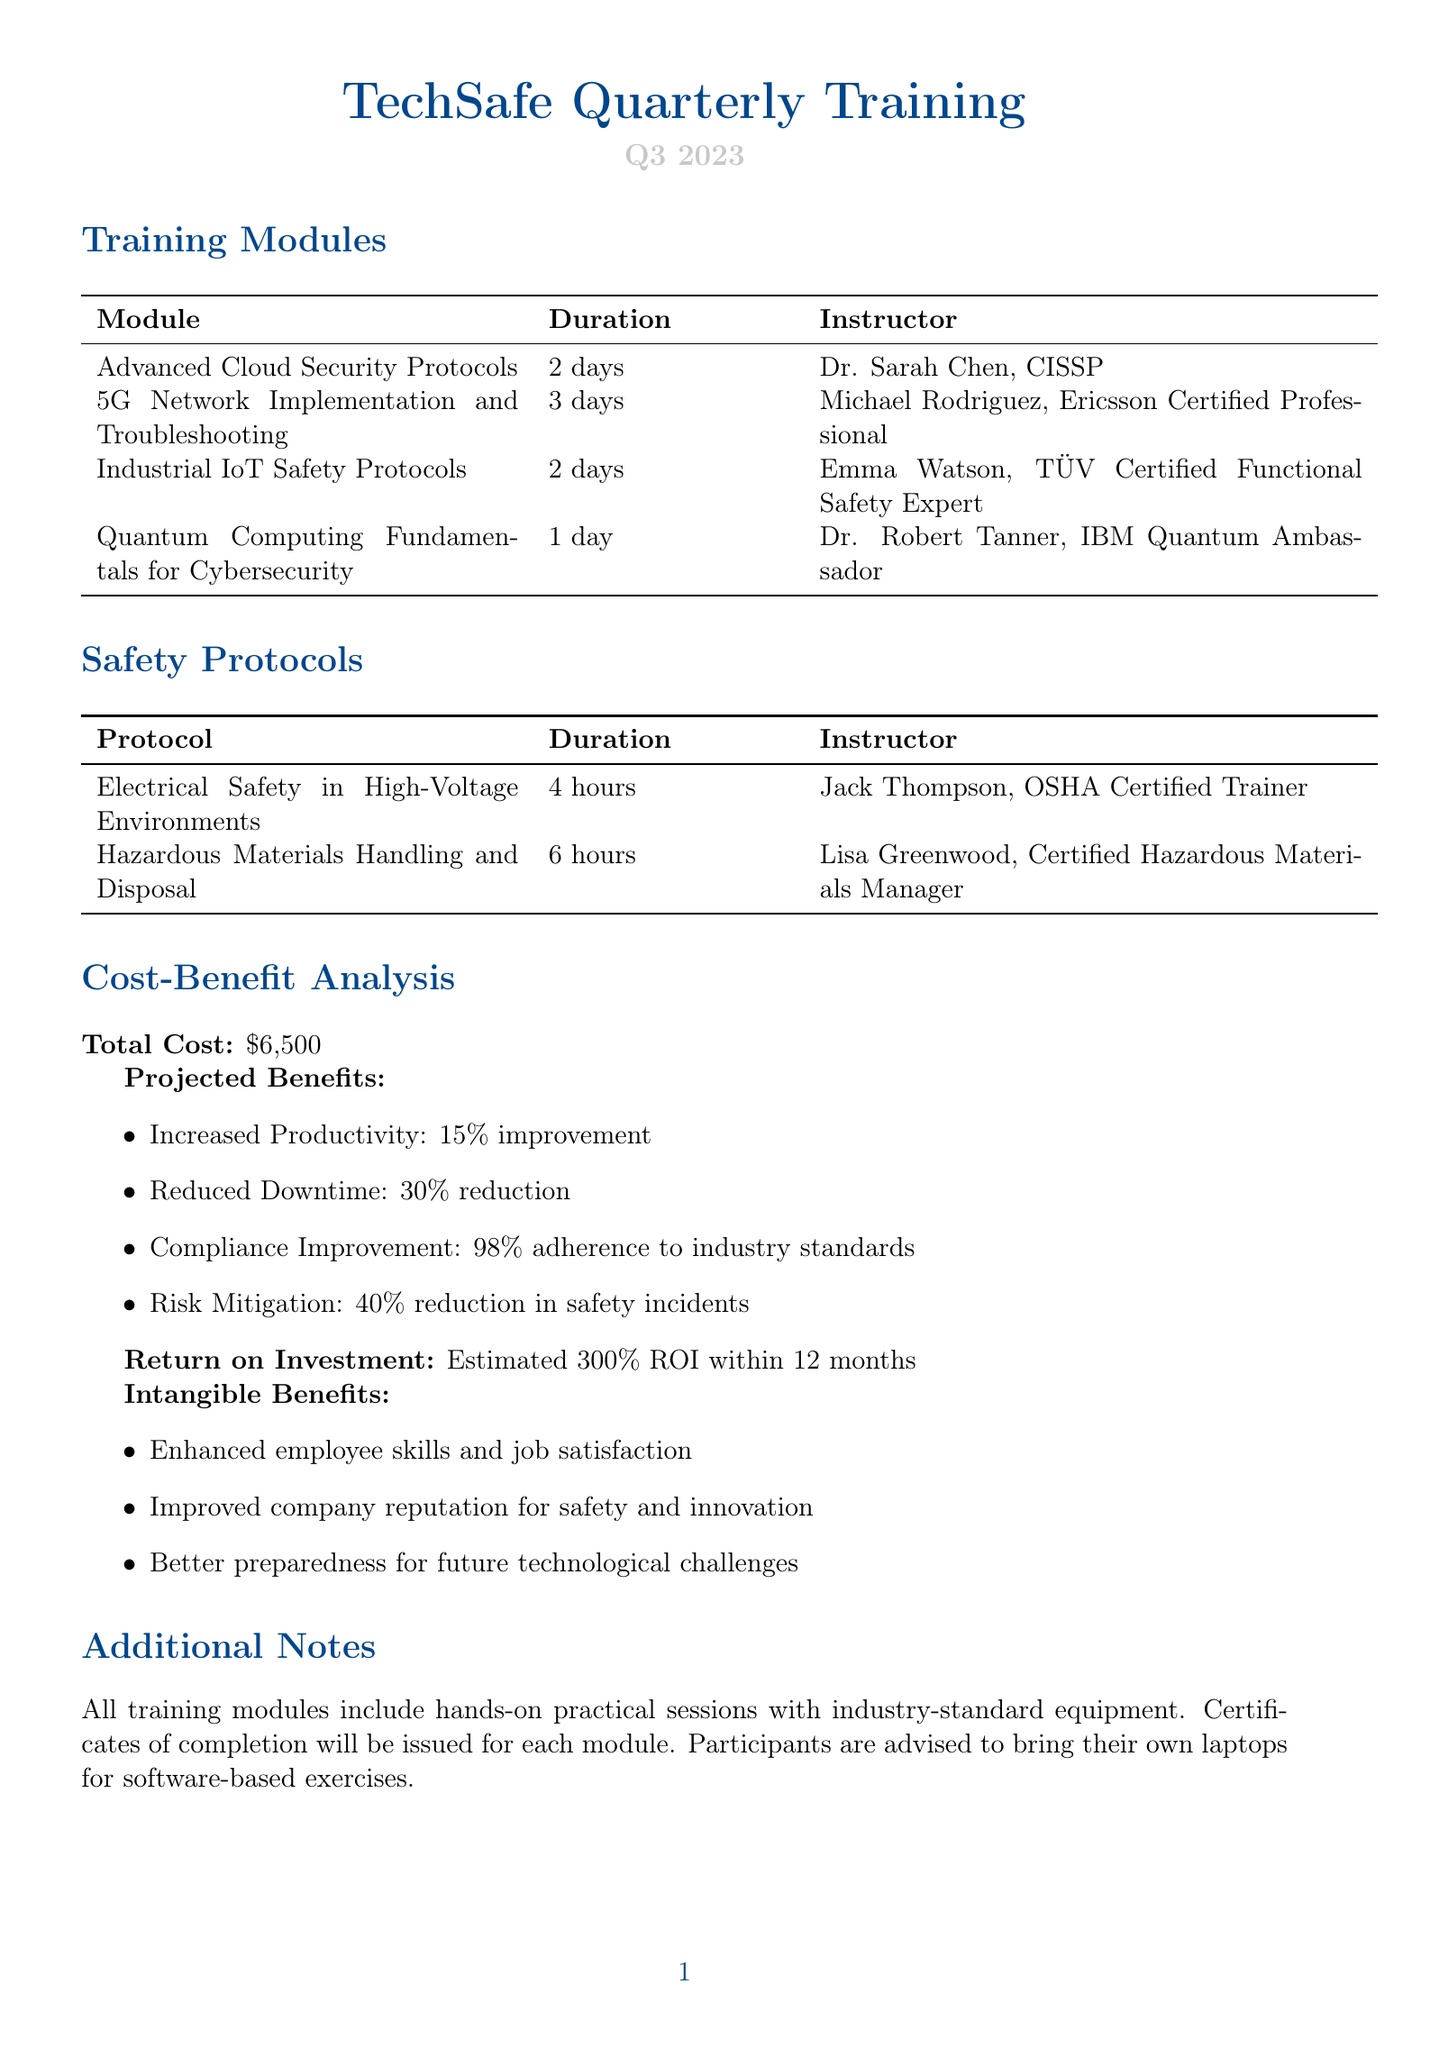what is the total cost of the training program? The total cost listed in the document is \$6,500.
Answer: \$6,500 who is the instructor for the "Advanced Cloud Security Protocols" module? The instructor for this module is Dr. Sarah Chen, CISSP.
Answer: Dr. Sarah Chen, CISSP how many days does the "5G Network Implementation and Troubleshooting" training last? The duration of this training is specified as 3 days.
Answer: 3 days what is one of the projected benefits mentioned in the cost-benefit analysis? The document lists several projected benefits, one of which is a 15% improvement in productivity.
Answer: 15% improvement what is the estimated return on investment for the training program? The estimated return on investment stated in the document is 300% ROI within 12 months.
Answer: 300% ROI within 12 months how long is the "Electrical Safety in High-Voltage Environments" training? The duration of this training protocol is mentioned as 4 hours.
Answer: 4 hours who is the instructor for the "Hazardous Materials Handling and Disposal" protocol? The instructor for this safety protocol is Lisa Greenwood, Certified Hazardous Materials Manager.
Answer: Lisa Greenwood, Certified Hazardous Materials Manager which technology is included in the "Industrial IoT Safety Protocols" training? One of the technologies included is the Siemens SIMATIC IOT2050.
Answer: Siemens SIMATIC IOT2050 what is included in the additional notes of the training program? The additional notes specify that all training modules include hands-on practical sessions with industry-standard equipment.
Answer: Hands-on practical sessions with industry-standard equipment 